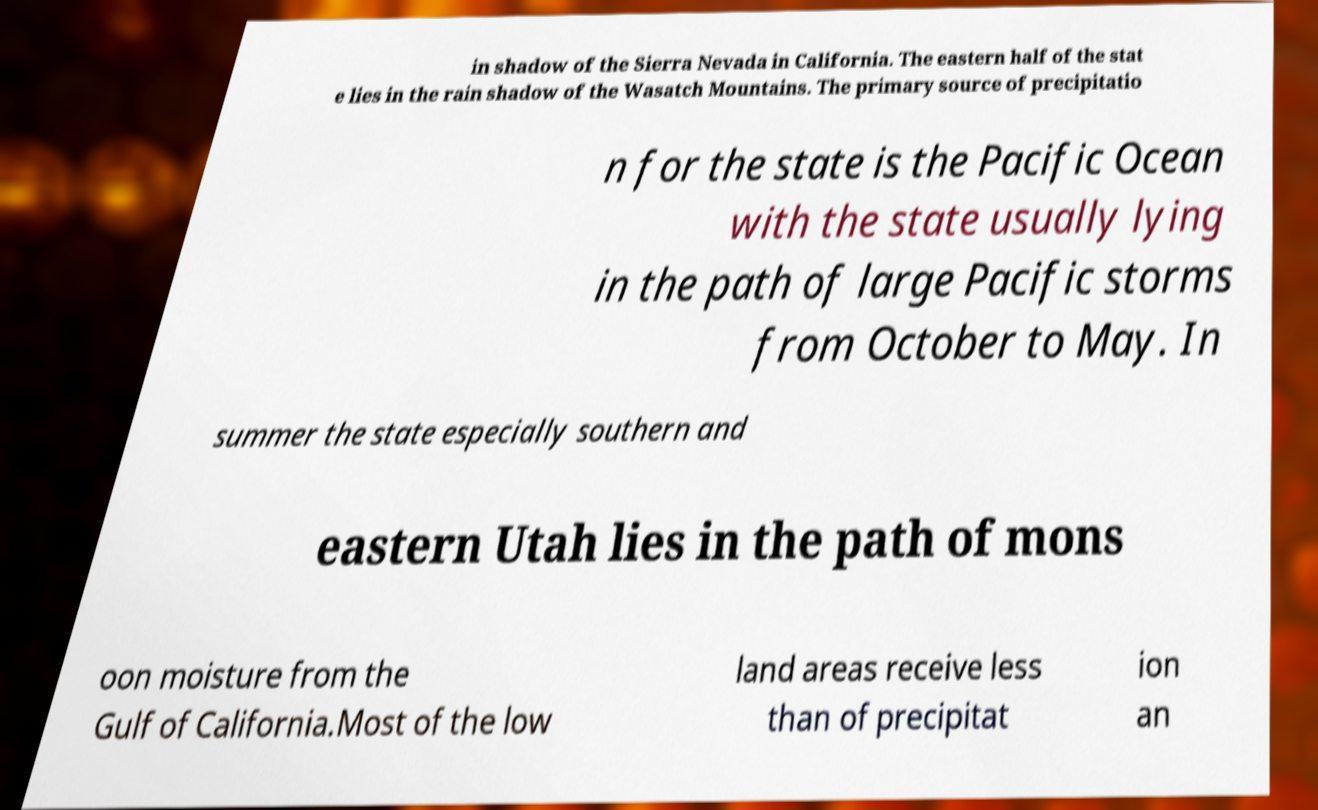I need the written content from this picture converted into text. Can you do that? in shadow of the Sierra Nevada in California. The eastern half of the stat e lies in the rain shadow of the Wasatch Mountains. The primary source of precipitatio n for the state is the Pacific Ocean with the state usually lying in the path of large Pacific storms from October to May. In summer the state especially southern and eastern Utah lies in the path of mons oon moisture from the Gulf of California.Most of the low land areas receive less than of precipitat ion an 